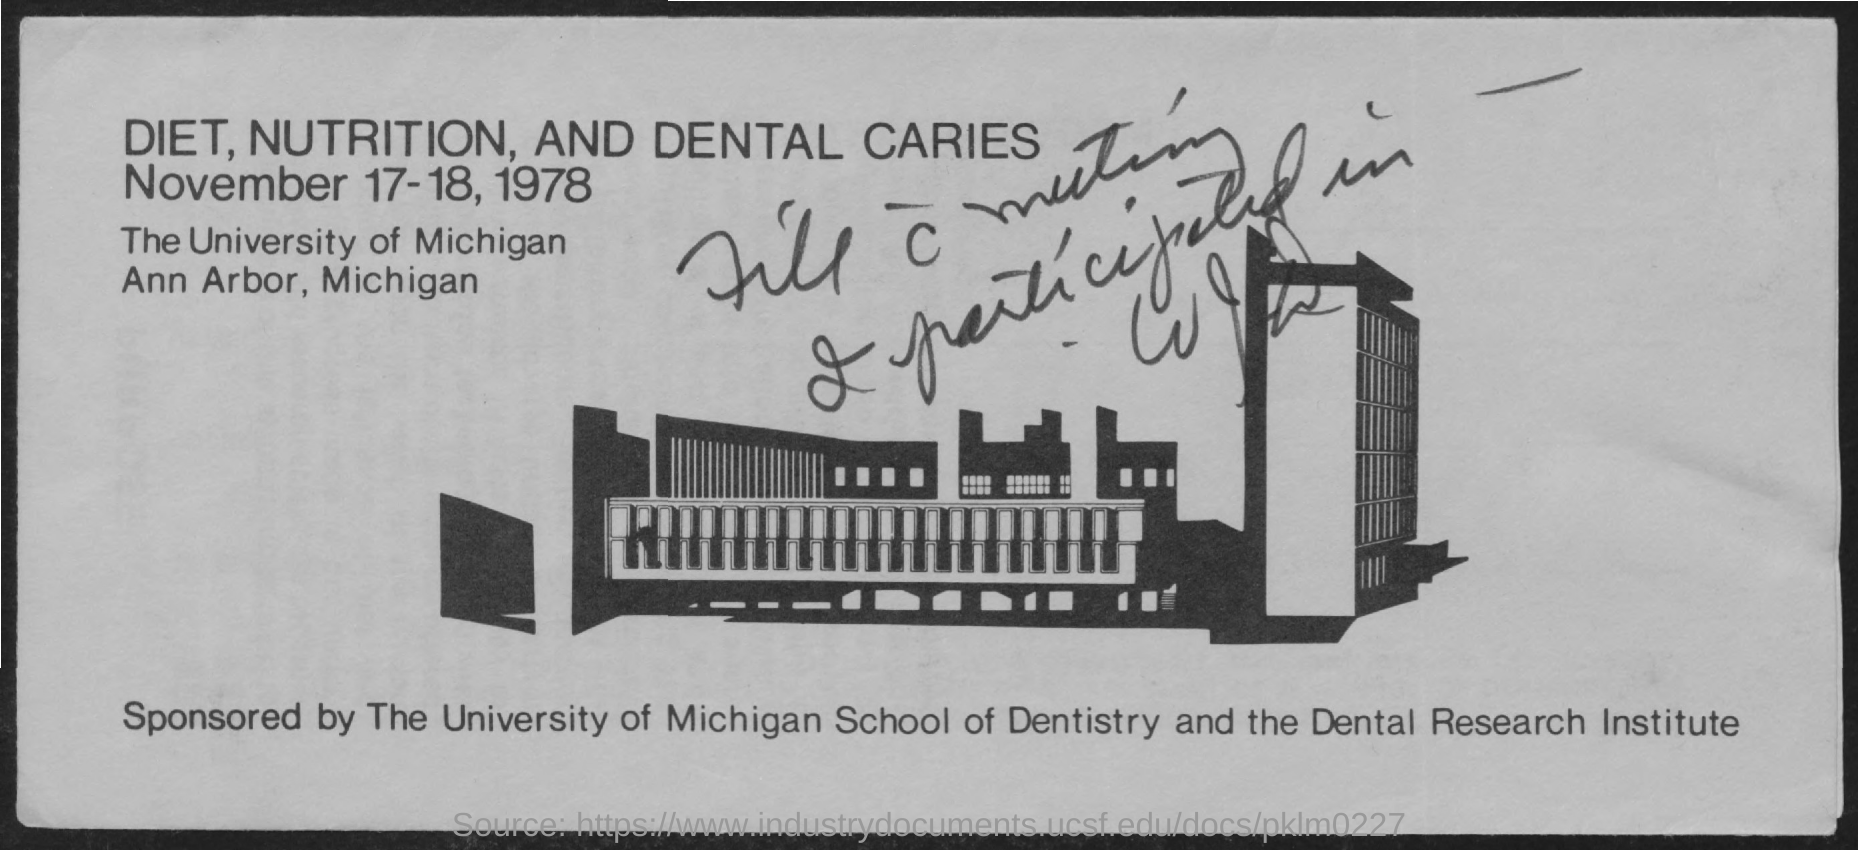List a handful of essential elements in this visual. The University of Michigan is located in Ann Arbor, Michigan. The date mentioned is November 17-18, 1978. The name of the university is The University of Michigan. 